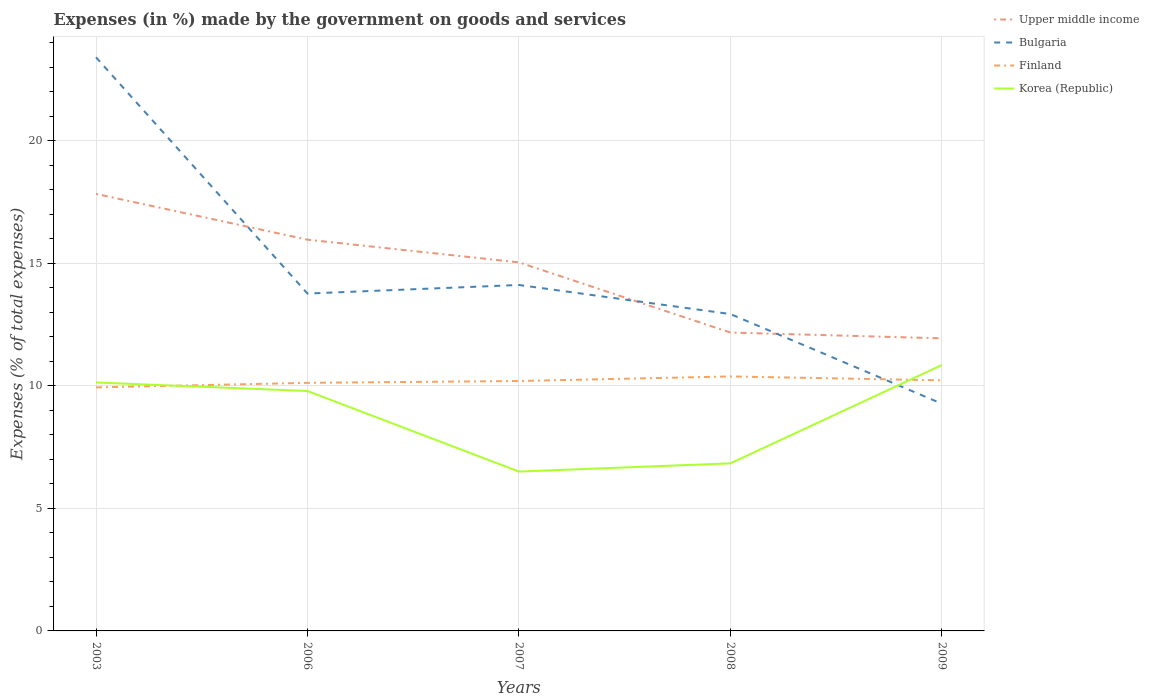Does the line corresponding to Upper middle income intersect with the line corresponding to Finland?
Give a very brief answer. No. Across all years, what is the maximum percentage of expenses made by the government on goods and services in Bulgaria?
Provide a succinct answer. 9.27. In which year was the percentage of expenses made by the government on goods and services in Upper middle income maximum?
Provide a succinct answer. 2009. What is the total percentage of expenses made by the government on goods and services in Korea (Republic) in the graph?
Provide a short and direct response. -0.71. What is the difference between the highest and the second highest percentage of expenses made by the government on goods and services in Korea (Republic)?
Offer a terse response. 4.35. What is the difference between the highest and the lowest percentage of expenses made by the government on goods and services in Upper middle income?
Your response must be concise. 3. What is the difference between two consecutive major ticks on the Y-axis?
Your response must be concise. 5. Are the values on the major ticks of Y-axis written in scientific E-notation?
Provide a succinct answer. No. Does the graph contain any zero values?
Ensure brevity in your answer.  No. How many legend labels are there?
Provide a short and direct response. 4. How are the legend labels stacked?
Ensure brevity in your answer.  Vertical. What is the title of the graph?
Offer a very short reply. Expenses (in %) made by the government on goods and services. What is the label or title of the Y-axis?
Offer a terse response. Expenses (% of total expenses). What is the Expenses (% of total expenses) in Upper middle income in 2003?
Offer a very short reply. 17.82. What is the Expenses (% of total expenses) in Bulgaria in 2003?
Provide a short and direct response. 23.4. What is the Expenses (% of total expenses) of Finland in 2003?
Ensure brevity in your answer.  9.93. What is the Expenses (% of total expenses) of Korea (Republic) in 2003?
Your answer should be compact. 10.13. What is the Expenses (% of total expenses) in Upper middle income in 2006?
Your answer should be very brief. 15.96. What is the Expenses (% of total expenses) in Bulgaria in 2006?
Make the answer very short. 13.76. What is the Expenses (% of total expenses) in Finland in 2006?
Keep it short and to the point. 10.12. What is the Expenses (% of total expenses) in Korea (Republic) in 2006?
Give a very brief answer. 9.79. What is the Expenses (% of total expenses) in Upper middle income in 2007?
Offer a very short reply. 15.03. What is the Expenses (% of total expenses) in Bulgaria in 2007?
Offer a very short reply. 14.11. What is the Expenses (% of total expenses) in Finland in 2007?
Give a very brief answer. 10.19. What is the Expenses (% of total expenses) of Korea (Republic) in 2007?
Your answer should be compact. 6.5. What is the Expenses (% of total expenses) in Upper middle income in 2008?
Keep it short and to the point. 12.17. What is the Expenses (% of total expenses) in Bulgaria in 2008?
Your response must be concise. 12.92. What is the Expenses (% of total expenses) of Finland in 2008?
Your response must be concise. 10.38. What is the Expenses (% of total expenses) in Korea (Republic) in 2008?
Offer a very short reply. 6.83. What is the Expenses (% of total expenses) of Upper middle income in 2009?
Make the answer very short. 11.93. What is the Expenses (% of total expenses) of Bulgaria in 2009?
Offer a terse response. 9.27. What is the Expenses (% of total expenses) of Finland in 2009?
Your answer should be very brief. 10.22. What is the Expenses (% of total expenses) of Korea (Republic) in 2009?
Your response must be concise. 10.85. Across all years, what is the maximum Expenses (% of total expenses) of Upper middle income?
Give a very brief answer. 17.82. Across all years, what is the maximum Expenses (% of total expenses) of Bulgaria?
Offer a terse response. 23.4. Across all years, what is the maximum Expenses (% of total expenses) in Finland?
Give a very brief answer. 10.38. Across all years, what is the maximum Expenses (% of total expenses) in Korea (Republic)?
Your answer should be compact. 10.85. Across all years, what is the minimum Expenses (% of total expenses) in Upper middle income?
Keep it short and to the point. 11.93. Across all years, what is the minimum Expenses (% of total expenses) in Bulgaria?
Your answer should be compact. 9.27. Across all years, what is the minimum Expenses (% of total expenses) in Finland?
Offer a very short reply. 9.93. Across all years, what is the minimum Expenses (% of total expenses) of Korea (Republic)?
Provide a succinct answer. 6.5. What is the total Expenses (% of total expenses) of Upper middle income in the graph?
Provide a succinct answer. 72.92. What is the total Expenses (% of total expenses) in Bulgaria in the graph?
Make the answer very short. 73.46. What is the total Expenses (% of total expenses) in Finland in the graph?
Your answer should be very brief. 50.84. What is the total Expenses (% of total expenses) of Korea (Republic) in the graph?
Give a very brief answer. 44.1. What is the difference between the Expenses (% of total expenses) in Upper middle income in 2003 and that in 2006?
Your response must be concise. 1.87. What is the difference between the Expenses (% of total expenses) of Bulgaria in 2003 and that in 2006?
Your answer should be very brief. 9.64. What is the difference between the Expenses (% of total expenses) of Finland in 2003 and that in 2006?
Your answer should be compact. -0.19. What is the difference between the Expenses (% of total expenses) of Korea (Republic) in 2003 and that in 2006?
Make the answer very short. 0.35. What is the difference between the Expenses (% of total expenses) in Upper middle income in 2003 and that in 2007?
Offer a very short reply. 2.79. What is the difference between the Expenses (% of total expenses) in Bulgaria in 2003 and that in 2007?
Your answer should be very brief. 9.29. What is the difference between the Expenses (% of total expenses) of Finland in 2003 and that in 2007?
Provide a succinct answer. -0.26. What is the difference between the Expenses (% of total expenses) of Korea (Republic) in 2003 and that in 2007?
Ensure brevity in your answer.  3.63. What is the difference between the Expenses (% of total expenses) in Upper middle income in 2003 and that in 2008?
Keep it short and to the point. 5.66. What is the difference between the Expenses (% of total expenses) of Bulgaria in 2003 and that in 2008?
Ensure brevity in your answer.  10.47. What is the difference between the Expenses (% of total expenses) of Finland in 2003 and that in 2008?
Keep it short and to the point. -0.45. What is the difference between the Expenses (% of total expenses) in Korea (Republic) in 2003 and that in 2008?
Keep it short and to the point. 3.3. What is the difference between the Expenses (% of total expenses) of Upper middle income in 2003 and that in 2009?
Provide a short and direct response. 5.89. What is the difference between the Expenses (% of total expenses) of Bulgaria in 2003 and that in 2009?
Give a very brief answer. 14.13. What is the difference between the Expenses (% of total expenses) in Finland in 2003 and that in 2009?
Make the answer very short. -0.29. What is the difference between the Expenses (% of total expenses) in Korea (Republic) in 2003 and that in 2009?
Offer a very short reply. -0.71. What is the difference between the Expenses (% of total expenses) in Upper middle income in 2006 and that in 2007?
Provide a short and direct response. 0.93. What is the difference between the Expenses (% of total expenses) of Bulgaria in 2006 and that in 2007?
Provide a succinct answer. -0.35. What is the difference between the Expenses (% of total expenses) in Finland in 2006 and that in 2007?
Keep it short and to the point. -0.08. What is the difference between the Expenses (% of total expenses) of Korea (Republic) in 2006 and that in 2007?
Ensure brevity in your answer.  3.29. What is the difference between the Expenses (% of total expenses) in Upper middle income in 2006 and that in 2008?
Make the answer very short. 3.79. What is the difference between the Expenses (% of total expenses) of Bulgaria in 2006 and that in 2008?
Keep it short and to the point. 0.84. What is the difference between the Expenses (% of total expenses) of Finland in 2006 and that in 2008?
Keep it short and to the point. -0.26. What is the difference between the Expenses (% of total expenses) in Korea (Republic) in 2006 and that in 2008?
Offer a terse response. 2.95. What is the difference between the Expenses (% of total expenses) of Upper middle income in 2006 and that in 2009?
Ensure brevity in your answer.  4.02. What is the difference between the Expenses (% of total expenses) of Bulgaria in 2006 and that in 2009?
Provide a short and direct response. 4.49. What is the difference between the Expenses (% of total expenses) in Finland in 2006 and that in 2009?
Offer a very short reply. -0.1. What is the difference between the Expenses (% of total expenses) of Korea (Republic) in 2006 and that in 2009?
Provide a succinct answer. -1.06. What is the difference between the Expenses (% of total expenses) of Upper middle income in 2007 and that in 2008?
Your answer should be compact. 2.86. What is the difference between the Expenses (% of total expenses) of Bulgaria in 2007 and that in 2008?
Give a very brief answer. 1.19. What is the difference between the Expenses (% of total expenses) in Finland in 2007 and that in 2008?
Your answer should be compact. -0.19. What is the difference between the Expenses (% of total expenses) in Korea (Republic) in 2007 and that in 2008?
Provide a succinct answer. -0.33. What is the difference between the Expenses (% of total expenses) in Upper middle income in 2007 and that in 2009?
Keep it short and to the point. 3.1. What is the difference between the Expenses (% of total expenses) of Bulgaria in 2007 and that in 2009?
Provide a succinct answer. 4.84. What is the difference between the Expenses (% of total expenses) in Finland in 2007 and that in 2009?
Ensure brevity in your answer.  -0.03. What is the difference between the Expenses (% of total expenses) in Korea (Republic) in 2007 and that in 2009?
Provide a short and direct response. -4.35. What is the difference between the Expenses (% of total expenses) of Upper middle income in 2008 and that in 2009?
Your answer should be very brief. 0.24. What is the difference between the Expenses (% of total expenses) of Bulgaria in 2008 and that in 2009?
Offer a very short reply. 3.66. What is the difference between the Expenses (% of total expenses) in Finland in 2008 and that in 2009?
Offer a very short reply. 0.16. What is the difference between the Expenses (% of total expenses) in Korea (Republic) in 2008 and that in 2009?
Offer a very short reply. -4.01. What is the difference between the Expenses (% of total expenses) in Upper middle income in 2003 and the Expenses (% of total expenses) in Bulgaria in 2006?
Your answer should be very brief. 4.06. What is the difference between the Expenses (% of total expenses) of Upper middle income in 2003 and the Expenses (% of total expenses) of Finland in 2006?
Provide a short and direct response. 7.71. What is the difference between the Expenses (% of total expenses) of Upper middle income in 2003 and the Expenses (% of total expenses) of Korea (Republic) in 2006?
Make the answer very short. 8.04. What is the difference between the Expenses (% of total expenses) of Bulgaria in 2003 and the Expenses (% of total expenses) of Finland in 2006?
Give a very brief answer. 13.28. What is the difference between the Expenses (% of total expenses) in Bulgaria in 2003 and the Expenses (% of total expenses) in Korea (Republic) in 2006?
Give a very brief answer. 13.61. What is the difference between the Expenses (% of total expenses) of Finland in 2003 and the Expenses (% of total expenses) of Korea (Republic) in 2006?
Offer a very short reply. 0.15. What is the difference between the Expenses (% of total expenses) in Upper middle income in 2003 and the Expenses (% of total expenses) in Bulgaria in 2007?
Provide a short and direct response. 3.72. What is the difference between the Expenses (% of total expenses) of Upper middle income in 2003 and the Expenses (% of total expenses) of Finland in 2007?
Your answer should be compact. 7.63. What is the difference between the Expenses (% of total expenses) of Upper middle income in 2003 and the Expenses (% of total expenses) of Korea (Republic) in 2007?
Your answer should be very brief. 11.33. What is the difference between the Expenses (% of total expenses) of Bulgaria in 2003 and the Expenses (% of total expenses) of Finland in 2007?
Give a very brief answer. 13.2. What is the difference between the Expenses (% of total expenses) in Bulgaria in 2003 and the Expenses (% of total expenses) in Korea (Republic) in 2007?
Provide a succinct answer. 16.9. What is the difference between the Expenses (% of total expenses) of Finland in 2003 and the Expenses (% of total expenses) of Korea (Republic) in 2007?
Make the answer very short. 3.43. What is the difference between the Expenses (% of total expenses) in Upper middle income in 2003 and the Expenses (% of total expenses) in Bulgaria in 2008?
Your answer should be compact. 4.9. What is the difference between the Expenses (% of total expenses) of Upper middle income in 2003 and the Expenses (% of total expenses) of Finland in 2008?
Provide a succinct answer. 7.45. What is the difference between the Expenses (% of total expenses) of Upper middle income in 2003 and the Expenses (% of total expenses) of Korea (Republic) in 2008?
Provide a succinct answer. 10.99. What is the difference between the Expenses (% of total expenses) of Bulgaria in 2003 and the Expenses (% of total expenses) of Finland in 2008?
Ensure brevity in your answer.  13.02. What is the difference between the Expenses (% of total expenses) of Bulgaria in 2003 and the Expenses (% of total expenses) of Korea (Republic) in 2008?
Provide a succinct answer. 16.56. What is the difference between the Expenses (% of total expenses) in Finland in 2003 and the Expenses (% of total expenses) in Korea (Republic) in 2008?
Give a very brief answer. 3.1. What is the difference between the Expenses (% of total expenses) of Upper middle income in 2003 and the Expenses (% of total expenses) of Bulgaria in 2009?
Your answer should be very brief. 8.56. What is the difference between the Expenses (% of total expenses) in Upper middle income in 2003 and the Expenses (% of total expenses) in Finland in 2009?
Your answer should be very brief. 7.6. What is the difference between the Expenses (% of total expenses) of Upper middle income in 2003 and the Expenses (% of total expenses) of Korea (Republic) in 2009?
Make the answer very short. 6.98. What is the difference between the Expenses (% of total expenses) of Bulgaria in 2003 and the Expenses (% of total expenses) of Finland in 2009?
Keep it short and to the point. 13.18. What is the difference between the Expenses (% of total expenses) of Bulgaria in 2003 and the Expenses (% of total expenses) of Korea (Republic) in 2009?
Ensure brevity in your answer.  12.55. What is the difference between the Expenses (% of total expenses) of Finland in 2003 and the Expenses (% of total expenses) of Korea (Republic) in 2009?
Make the answer very short. -0.91. What is the difference between the Expenses (% of total expenses) of Upper middle income in 2006 and the Expenses (% of total expenses) of Bulgaria in 2007?
Your response must be concise. 1.85. What is the difference between the Expenses (% of total expenses) of Upper middle income in 2006 and the Expenses (% of total expenses) of Finland in 2007?
Offer a terse response. 5.76. What is the difference between the Expenses (% of total expenses) of Upper middle income in 2006 and the Expenses (% of total expenses) of Korea (Republic) in 2007?
Give a very brief answer. 9.46. What is the difference between the Expenses (% of total expenses) in Bulgaria in 2006 and the Expenses (% of total expenses) in Finland in 2007?
Keep it short and to the point. 3.57. What is the difference between the Expenses (% of total expenses) in Bulgaria in 2006 and the Expenses (% of total expenses) in Korea (Republic) in 2007?
Your answer should be very brief. 7.26. What is the difference between the Expenses (% of total expenses) in Finland in 2006 and the Expenses (% of total expenses) in Korea (Republic) in 2007?
Your response must be concise. 3.62. What is the difference between the Expenses (% of total expenses) in Upper middle income in 2006 and the Expenses (% of total expenses) in Bulgaria in 2008?
Provide a succinct answer. 3.03. What is the difference between the Expenses (% of total expenses) of Upper middle income in 2006 and the Expenses (% of total expenses) of Finland in 2008?
Make the answer very short. 5.58. What is the difference between the Expenses (% of total expenses) in Upper middle income in 2006 and the Expenses (% of total expenses) in Korea (Republic) in 2008?
Your answer should be compact. 9.12. What is the difference between the Expenses (% of total expenses) of Bulgaria in 2006 and the Expenses (% of total expenses) of Finland in 2008?
Offer a terse response. 3.38. What is the difference between the Expenses (% of total expenses) in Bulgaria in 2006 and the Expenses (% of total expenses) in Korea (Republic) in 2008?
Give a very brief answer. 6.93. What is the difference between the Expenses (% of total expenses) of Finland in 2006 and the Expenses (% of total expenses) of Korea (Republic) in 2008?
Keep it short and to the point. 3.28. What is the difference between the Expenses (% of total expenses) in Upper middle income in 2006 and the Expenses (% of total expenses) in Bulgaria in 2009?
Make the answer very short. 6.69. What is the difference between the Expenses (% of total expenses) in Upper middle income in 2006 and the Expenses (% of total expenses) in Finland in 2009?
Offer a terse response. 5.74. What is the difference between the Expenses (% of total expenses) of Upper middle income in 2006 and the Expenses (% of total expenses) of Korea (Republic) in 2009?
Keep it short and to the point. 5.11. What is the difference between the Expenses (% of total expenses) of Bulgaria in 2006 and the Expenses (% of total expenses) of Finland in 2009?
Keep it short and to the point. 3.54. What is the difference between the Expenses (% of total expenses) of Bulgaria in 2006 and the Expenses (% of total expenses) of Korea (Republic) in 2009?
Offer a very short reply. 2.91. What is the difference between the Expenses (% of total expenses) of Finland in 2006 and the Expenses (% of total expenses) of Korea (Republic) in 2009?
Your answer should be very brief. -0.73. What is the difference between the Expenses (% of total expenses) in Upper middle income in 2007 and the Expenses (% of total expenses) in Bulgaria in 2008?
Offer a terse response. 2.11. What is the difference between the Expenses (% of total expenses) of Upper middle income in 2007 and the Expenses (% of total expenses) of Finland in 2008?
Your answer should be compact. 4.65. What is the difference between the Expenses (% of total expenses) in Upper middle income in 2007 and the Expenses (% of total expenses) in Korea (Republic) in 2008?
Offer a terse response. 8.2. What is the difference between the Expenses (% of total expenses) in Bulgaria in 2007 and the Expenses (% of total expenses) in Finland in 2008?
Offer a terse response. 3.73. What is the difference between the Expenses (% of total expenses) in Bulgaria in 2007 and the Expenses (% of total expenses) in Korea (Republic) in 2008?
Keep it short and to the point. 7.28. What is the difference between the Expenses (% of total expenses) in Finland in 2007 and the Expenses (% of total expenses) in Korea (Republic) in 2008?
Offer a terse response. 3.36. What is the difference between the Expenses (% of total expenses) of Upper middle income in 2007 and the Expenses (% of total expenses) of Bulgaria in 2009?
Keep it short and to the point. 5.77. What is the difference between the Expenses (% of total expenses) of Upper middle income in 2007 and the Expenses (% of total expenses) of Finland in 2009?
Keep it short and to the point. 4.81. What is the difference between the Expenses (% of total expenses) in Upper middle income in 2007 and the Expenses (% of total expenses) in Korea (Republic) in 2009?
Keep it short and to the point. 4.19. What is the difference between the Expenses (% of total expenses) of Bulgaria in 2007 and the Expenses (% of total expenses) of Finland in 2009?
Your answer should be very brief. 3.89. What is the difference between the Expenses (% of total expenses) of Bulgaria in 2007 and the Expenses (% of total expenses) of Korea (Republic) in 2009?
Give a very brief answer. 3.26. What is the difference between the Expenses (% of total expenses) of Finland in 2007 and the Expenses (% of total expenses) of Korea (Republic) in 2009?
Your answer should be very brief. -0.65. What is the difference between the Expenses (% of total expenses) in Upper middle income in 2008 and the Expenses (% of total expenses) in Bulgaria in 2009?
Make the answer very short. 2.9. What is the difference between the Expenses (% of total expenses) of Upper middle income in 2008 and the Expenses (% of total expenses) of Finland in 2009?
Ensure brevity in your answer.  1.95. What is the difference between the Expenses (% of total expenses) of Upper middle income in 2008 and the Expenses (% of total expenses) of Korea (Republic) in 2009?
Provide a short and direct response. 1.32. What is the difference between the Expenses (% of total expenses) of Bulgaria in 2008 and the Expenses (% of total expenses) of Finland in 2009?
Your answer should be very brief. 2.7. What is the difference between the Expenses (% of total expenses) in Bulgaria in 2008 and the Expenses (% of total expenses) in Korea (Republic) in 2009?
Offer a terse response. 2.08. What is the difference between the Expenses (% of total expenses) in Finland in 2008 and the Expenses (% of total expenses) in Korea (Republic) in 2009?
Provide a short and direct response. -0.47. What is the average Expenses (% of total expenses) in Upper middle income per year?
Your answer should be very brief. 14.58. What is the average Expenses (% of total expenses) in Bulgaria per year?
Keep it short and to the point. 14.69. What is the average Expenses (% of total expenses) of Finland per year?
Keep it short and to the point. 10.17. What is the average Expenses (% of total expenses) in Korea (Republic) per year?
Offer a terse response. 8.82. In the year 2003, what is the difference between the Expenses (% of total expenses) in Upper middle income and Expenses (% of total expenses) in Bulgaria?
Your answer should be compact. -5.57. In the year 2003, what is the difference between the Expenses (% of total expenses) in Upper middle income and Expenses (% of total expenses) in Finland?
Provide a short and direct response. 7.89. In the year 2003, what is the difference between the Expenses (% of total expenses) of Upper middle income and Expenses (% of total expenses) of Korea (Republic)?
Your response must be concise. 7.69. In the year 2003, what is the difference between the Expenses (% of total expenses) in Bulgaria and Expenses (% of total expenses) in Finland?
Offer a terse response. 13.46. In the year 2003, what is the difference between the Expenses (% of total expenses) of Bulgaria and Expenses (% of total expenses) of Korea (Republic)?
Provide a succinct answer. 13.26. In the year 2003, what is the difference between the Expenses (% of total expenses) in Finland and Expenses (% of total expenses) in Korea (Republic)?
Offer a very short reply. -0.2. In the year 2006, what is the difference between the Expenses (% of total expenses) in Upper middle income and Expenses (% of total expenses) in Bulgaria?
Offer a terse response. 2.2. In the year 2006, what is the difference between the Expenses (% of total expenses) in Upper middle income and Expenses (% of total expenses) in Finland?
Ensure brevity in your answer.  5.84. In the year 2006, what is the difference between the Expenses (% of total expenses) of Upper middle income and Expenses (% of total expenses) of Korea (Republic)?
Your answer should be compact. 6.17. In the year 2006, what is the difference between the Expenses (% of total expenses) in Bulgaria and Expenses (% of total expenses) in Finland?
Provide a succinct answer. 3.64. In the year 2006, what is the difference between the Expenses (% of total expenses) of Bulgaria and Expenses (% of total expenses) of Korea (Republic)?
Ensure brevity in your answer.  3.98. In the year 2006, what is the difference between the Expenses (% of total expenses) of Finland and Expenses (% of total expenses) of Korea (Republic)?
Ensure brevity in your answer.  0.33. In the year 2007, what is the difference between the Expenses (% of total expenses) of Upper middle income and Expenses (% of total expenses) of Bulgaria?
Provide a short and direct response. 0.92. In the year 2007, what is the difference between the Expenses (% of total expenses) in Upper middle income and Expenses (% of total expenses) in Finland?
Give a very brief answer. 4.84. In the year 2007, what is the difference between the Expenses (% of total expenses) in Upper middle income and Expenses (% of total expenses) in Korea (Republic)?
Offer a terse response. 8.53. In the year 2007, what is the difference between the Expenses (% of total expenses) in Bulgaria and Expenses (% of total expenses) in Finland?
Keep it short and to the point. 3.92. In the year 2007, what is the difference between the Expenses (% of total expenses) of Bulgaria and Expenses (% of total expenses) of Korea (Republic)?
Make the answer very short. 7.61. In the year 2007, what is the difference between the Expenses (% of total expenses) of Finland and Expenses (% of total expenses) of Korea (Republic)?
Your response must be concise. 3.69. In the year 2008, what is the difference between the Expenses (% of total expenses) in Upper middle income and Expenses (% of total expenses) in Bulgaria?
Provide a succinct answer. -0.75. In the year 2008, what is the difference between the Expenses (% of total expenses) of Upper middle income and Expenses (% of total expenses) of Finland?
Offer a terse response. 1.79. In the year 2008, what is the difference between the Expenses (% of total expenses) of Upper middle income and Expenses (% of total expenses) of Korea (Republic)?
Keep it short and to the point. 5.33. In the year 2008, what is the difference between the Expenses (% of total expenses) of Bulgaria and Expenses (% of total expenses) of Finland?
Your answer should be compact. 2.54. In the year 2008, what is the difference between the Expenses (% of total expenses) in Bulgaria and Expenses (% of total expenses) in Korea (Republic)?
Give a very brief answer. 6.09. In the year 2008, what is the difference between the Expenses (% of total expenses) in Finland and Expenses (% of total expenses) in Korea (Republic)?
Your answer should be compact. 3.54. In the year 2009, what is the difference between the Expenses (% of total expenses) in Upper middle income and Expenses (% of total expenses) in Bulgaria?
Provide a succinct answer. 2.67. In the year 2009, what is the difference between the Expenses (% of total expenses) of Upper middle income and Expenses (% of total expenses) of Finland?
Give a very brief answer. 1.71. In the year 2009, what is the difference between the Expenses (% of total expenses) of Upper middle income and Expenses (% of total expenses) of Korea (Republic)?
Your response must be concise. 1.09. In the year 2009, what is the difference between the Expenses (% of total expenses) in Bulgaria and Expenses (% of total expenses) in Finland?
Keep it short and to the point. -0.95. In the year 2009, what is the difference between the Expenses (% of total expenses) of Bulgaria and Expenses (% of total expenses) of Korea (Republic)?
Your answer should be very brief. -1.58. In the year 2009, what is the difference between the Expenses (% of total expenses) in Finland and Expenses (% of total expenses) in Korea (Republic)?
Your answer should be very brief. -0.62. What is the ratio of the Expenses (% of total expenses) in Upper middle income in 2003 to that in 2006?
Make the answer very short. 1.12. What is the ratio of the Expenses (% of total expenses) in Bulgaria in 2003 to that in 2006?
Give a very brief answer. 1.7. What is the ratio of the Expenses (% of total expenses) in Finland in 2003 to that in 2006?
Your answer should be very brief. 0.98. What is the ratio of the Expenses (% of total expenses) of Korea (Republic) in 2003 to that in 2006?
Make the answer very short. 1.04. What is the ratio of the Expenses (% of total expenses) in Upper middle income in 2003 to that in 2007?
Offer a very short reply. 1.19. What is the ratio of the Expenses (% of total expenses) in Bulgaria in 2003 to that in 2007?
Keep it short and to the point. 1.66. What is the ratio of the Expenses (% of total expenses) in Finland in 2003 to that in 2007?
Offer a terse response. 0.97. What is the ratio of the Expenses (% of total expenses) of Korea (Republic) in 2003 to that in 2007?
Keep it short and to the point. 1.56. What is the ratio of the Expenses (% of total expenses) in Upper middle income in 2003 to that in 2008?
Your answer should be very brief. 1.46. What is the ratio of the Expenses (% of total expenses) in Bulgaria in 2003 to that in 2008?
Provide a succinct answer. 1.81. What is the ratio of the Expenses (% of total expenses) in Korea (Republic) in 2003 to that in 2008?
Your response must be concise. 1.48. What is the ratio of the Expenses (% of total expenses) in Upper middle income in 2003 to that in 2009?
Make the answer very short. 1.49. What is the ratio of the Expenses (% of total expenses) in Bulgaria in 2003 to that in 2009?
Make the answer very short. 2.52. What is the ratio of the Expenses (% of total expenses) of Finland in 2003 to that in 2009?
Offer a very short reply. 0.97. What is the ratio of the Expenses (% of total expenses) of Korea (Republic) in 2003 to that in 2009?
Your response must be concise. 0.93. What is the ratio of the Expenses (% of total expenses) of Upper middle income in 2006 to that in 2007?
Make the answer very short. 1.06. What is the ratio of the Expenses (% of total expenses) of Bulgaria in 2006 to that in 2007?
Provide a succinct answer. 0.98. What is the ratio of the Expenses (% of total expenses) in Finland in 2006 to that in 2007?
Your response must be concise. 0.99. What is the ratio of the Expenses (% of total expenses) of Korea (Republic) in 2006 to that in 2007?
Your response must be concise. 1.51. What is the ratio of the Expenses (% of total expenses) in Upper middle income in 2006 to that in 2008?
Ensure brevity in your answer.  1.31. What is the ratio of the Expenses (% of total expenses) of Bulgaria in 2006 to that in 2008?
Offer a very short reply. 1.06. What is the ratio of the Expenses (% of total expenses) of Finland in 2006 to that in 2008?
Your answer should be compact. 0.97. What is the ratio of the Expenses (% of total expenses) in Korea (Republic) in 2006 to that in 2008?
Your answer should be compact. 1.43. What is the ratio of the Expenses (% of total expenses) in Upper middle income in 2006 to that in 2009?
Your answer should be compact. 1.34. What is the ratio of the Expenses (% of total expenses) of Bulgaria in 2006 to that in 2009?
Make the answer very short. 1.49. What is the ratio of the Expenses (% of total expenses) of Korea (Republic) in 2006 to that in 2009?
Provide a short and direct response. 0.9. What is the ratio of the Expenses (% of total expenses) in Upper middle income in 2007 to that in 2008?
Your answer should be compact. 1.24. What is the ratio of the Expenses (% of total expenses) of Bulgaria in 2007 to that in 2008?
Keep it short and to the point. 1.09. What is the ratio of the Expenses (% of total expenses) in Finland in 2007 to that in 2008?
Your answer should be very brief. 0.98. What is the ratio of the Expenses (% of total expenses) of Korea (Republic) in 2007 to that in 2008?
Make the answer very short. 0.95. What is the ratio of the Expenses (% of total expenses) in Upper middle income in 2007 to that in 2009?
Provide a succinct answer. 1.26. What is the ratio of the Expenses (% of total expenses) of Bulgaria in 2007 to that in 2009?
Offer a very short reply. 1.52. What is the ratio of the Expenses (% of total expenses) in Korea (Republic) in 2007 to that in 2009?
Your answer should be compact. 0.6. What is the ratio of the Expenses (% of total expenses) of Upper middle income in 2008 to that in 2009?
Ensure brevity in your answer.  1.02. What is the ratio of the Expenses (% of total expenses) in Bulgaria in 2008 to that in 2009?
Offer a terse response. 1.39. What is the ratio of the Expenses (% of total expenses) of Finland in 2008 to that in 2009?
Your answer should be very brief. 1.02. What is the ratio of the Expenses (% of total expenses) of Korea (Republic) in 2008 to that in 2009?
Provide a short and direct response. 0.63. What is the difference between the highest and the second highest Expenses (% of total expenses) of Upper middle income?
Keep it short and to the point. 1.87. What is the difference between the highest and the second highest Expenses (% of total expenses) of Bulgaria?
Offer a terse response. 9.29. What is the difference between the highest and the second highest Expenses (% of total expenses) in Finland?
Offer a terse response. 0.16. What is the difference between the highest and the second highest Expenses (% of total expenses) of Korea (Republic)?
Make the answer very short. 0.71. What is the difference between the highest and the lowest Expenses (% of total expenses) of Upper middle income?
Provide a short and direct response. 5.89. What is the difference between the highest and the lowest Expenses (% of total expenses) of Bulgaria?
Make the answer very short. 14.13. What is the difference between the highest and the lowest Expenses (% of total expenses) in Finland?
Give a very brief answer. 0.45. What is the difference between the highest and the lowest Expenses (% of total expenses) of Korea (Republic)?
Your answer should be very brief. 4.35. 